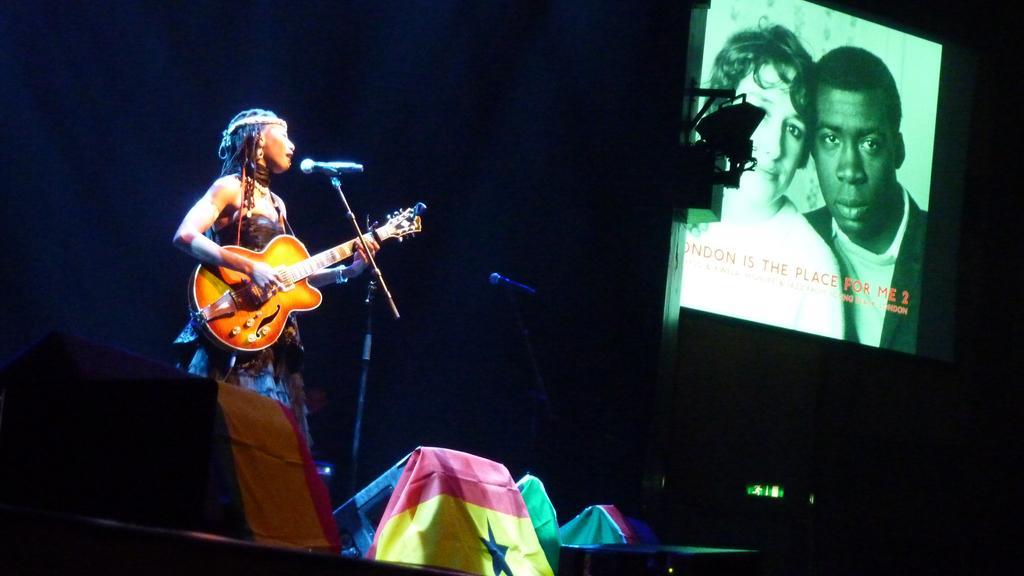Describe this image in one or two sentences. In this image a woman standing and holding a guitar is singing. Beside there is another mike. At the right side there is a screen with two persons. At the front side there are few flags. 